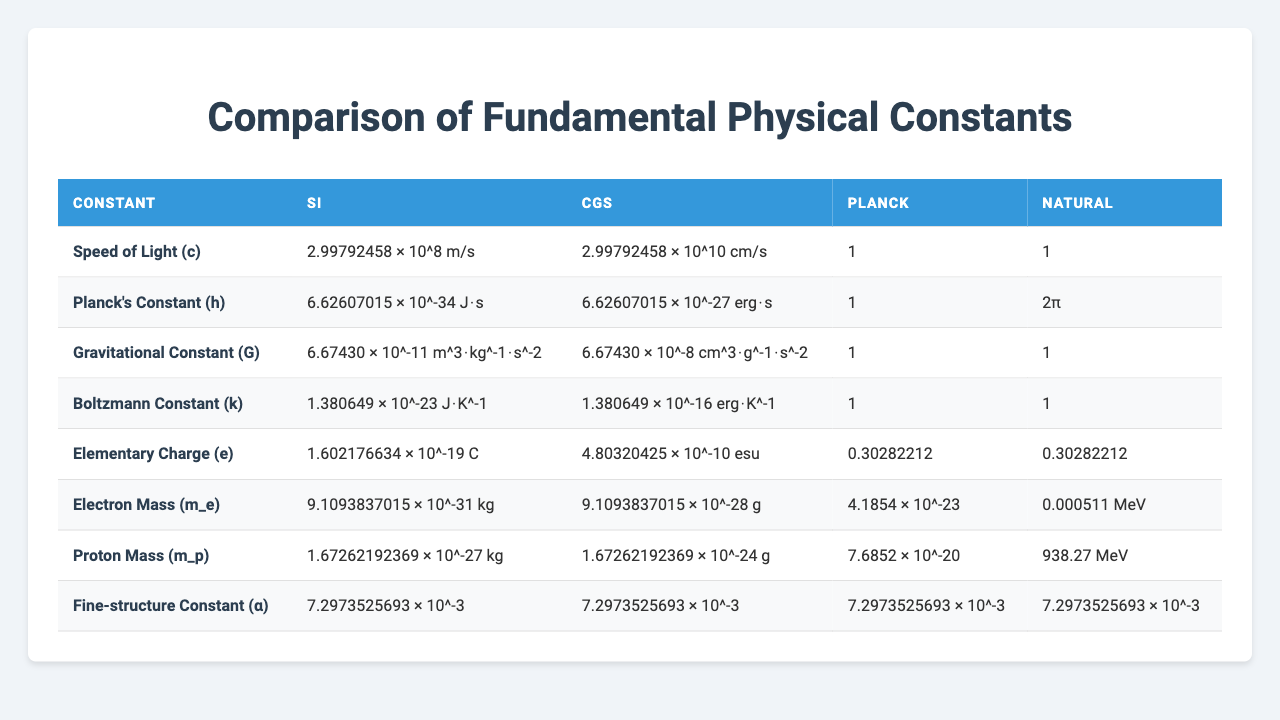What is the value of Planck's Constant in SI units? From the table, the value of Planck's Constant (h) in SI units is listed as 6.62607015 × 10^-34 J⋅s.
Answer: 6.62607015 × 10^-34 J⋅s Is the Fine-structure Constant the same across all measurement systems? The table shows that the value of the Fine-structure Constant (α) is 7.2973525693 × 10^-3 in all measurement systems: SI, CGS, Planck, and Natural. Therefore, yes, it is the same across all.
Answer: Yes What is the difference between the values of the Gravitational Constant in SI and CGS units? The value of the Gravitational Constant (G) in SI is 6.67430 × 10^-11 m^3⋅kg^-1⋅s^-2 and in CGS, it is 6.67430 × 10^-8 cm^3⋅g^-1⋅s^-2. Converting the SI value to CGS would involve multiplying by 10^5, resulting in the difference: (6.67430 × 10^-8) - (6.67430 × 10^-11 * 10^5) = 0. The two values are equivalent when properly converted.
Answer: 0 What is the ratio of the speeds of light in CGS and SI units? The speed of light (c) in SI is 2.99792458 × 10^8 m/s, and in CGS, it is 2.99792458 × 10^10 cm/s. To find the ratio, we convert the SI unit to CGS (1 m = 100 cm), which results in (2.99792458 × 10^8 m/s * 100) = 2.99792458 × 10^10 cm/s, thus the ratio of CGS to SI speed is 1:1.
Answer: 1:1 Is the value of the Electron Mass greater than the Proton Mass? From the values in the table, the Electron Mass (m_e) is 9.1093837015 × 10^-31 kg, while the Proton Mass (m_p) is 1.67262192369 × 10^-27 kg. Clearly, the Proton Mass is greater than the Electron Mass.
Answer: No What are the units of the Boltzmann Constant in both SI and CGS systems? The value of the Boltzmann Constant (k) in SI is given as 1.380649 × 10^-23 J⋅K^-1, and in the CGS system, it is 1.380649 × 10^-16 erg⋅K^-1. Both unit formats are consistent with their respective systems.
Answer: J⋅K^-1 and erg⋅K^-1 How does the value of the Elementary Charge compare in CGS and SI units? The value of the Elementary Charge (e) in SI is 1.602176634 × 10^-19 C, while in CGS, it is 4.80320425 × 10^-10 esu. To compare, we can observe that both measurements serve as units of electric charge in their respective systems.
Answer: C and esu Which constant has the smallest value in SI units? Reviewing the values in the table, the constant with the smallest value in SI is the Planck's Constant, listed as 6.62607015 × 10^-34 J⋅s.
Answer: Planck's Constant 